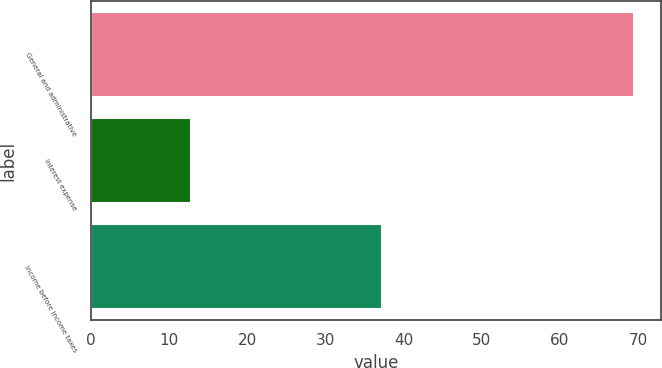Convert chart. <chart><loc_0><loc_0><loc_500><loc_500><bar_chart><fcel>General and administrative<fcel>Interest expense<fcel>Income before income taxes<nl><fcel>69.5<fcel>12.8<fcel>37.3<nl></chart> 